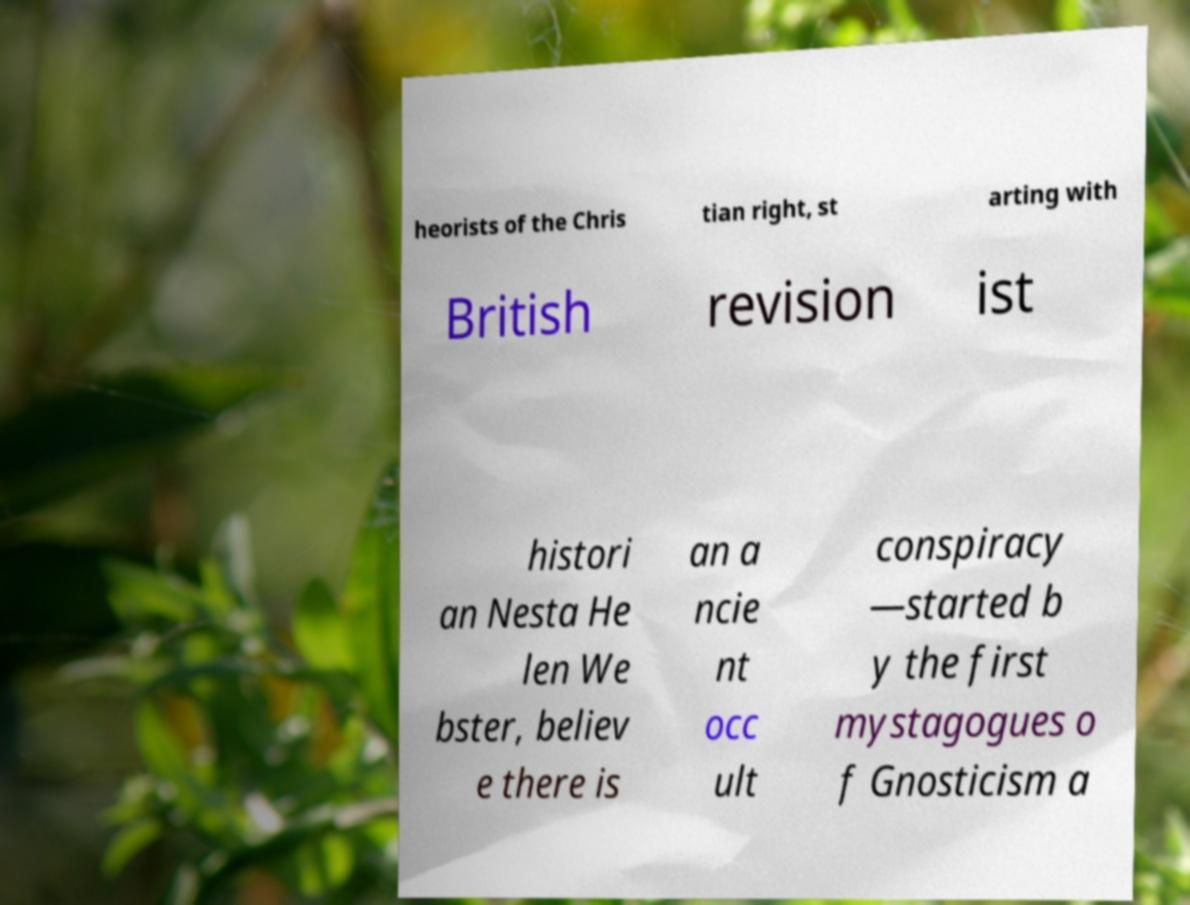Can you accurately transcribe the text from the provided image for me? heorists of the Chris tian right, st arting with British revision ist histori an Nesta He len We bster, believ e there is an a ncie nt occ ult conspiracy —started b y the first mystagogues o f Gnosticism a 